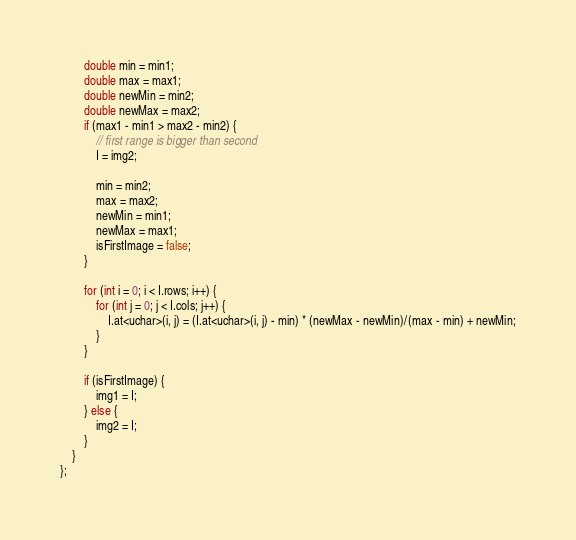Convert code to text. <code><loc_0><loc_0><loc_500><loc_500><_C++_>        double min = min1;
        double max = max1;
        double newMin = min2;
        double newMax = max2;
        if (max1 - min1 > max2 - min2) {
            // first range is bigger than second
            I = img2;
            
            min = min2;
            max = max2;
            newMin = min1;
            newMax = max1;
            isFirstImage = false;
        }
        
        for (int i = 0; i < I.rows; i++) {
            for (int j = 0; j < I.cols; j++) {
                I.at<uchar>(i, j) = (I.at<uchar>(i, j) - min) * (newMax - newMin)/(max - min) + newMin;
            }
        }
        
        if (isFirstImage) {
            img1 = I;
        } else {
            img2 = I;
        }
    }
};</code> 